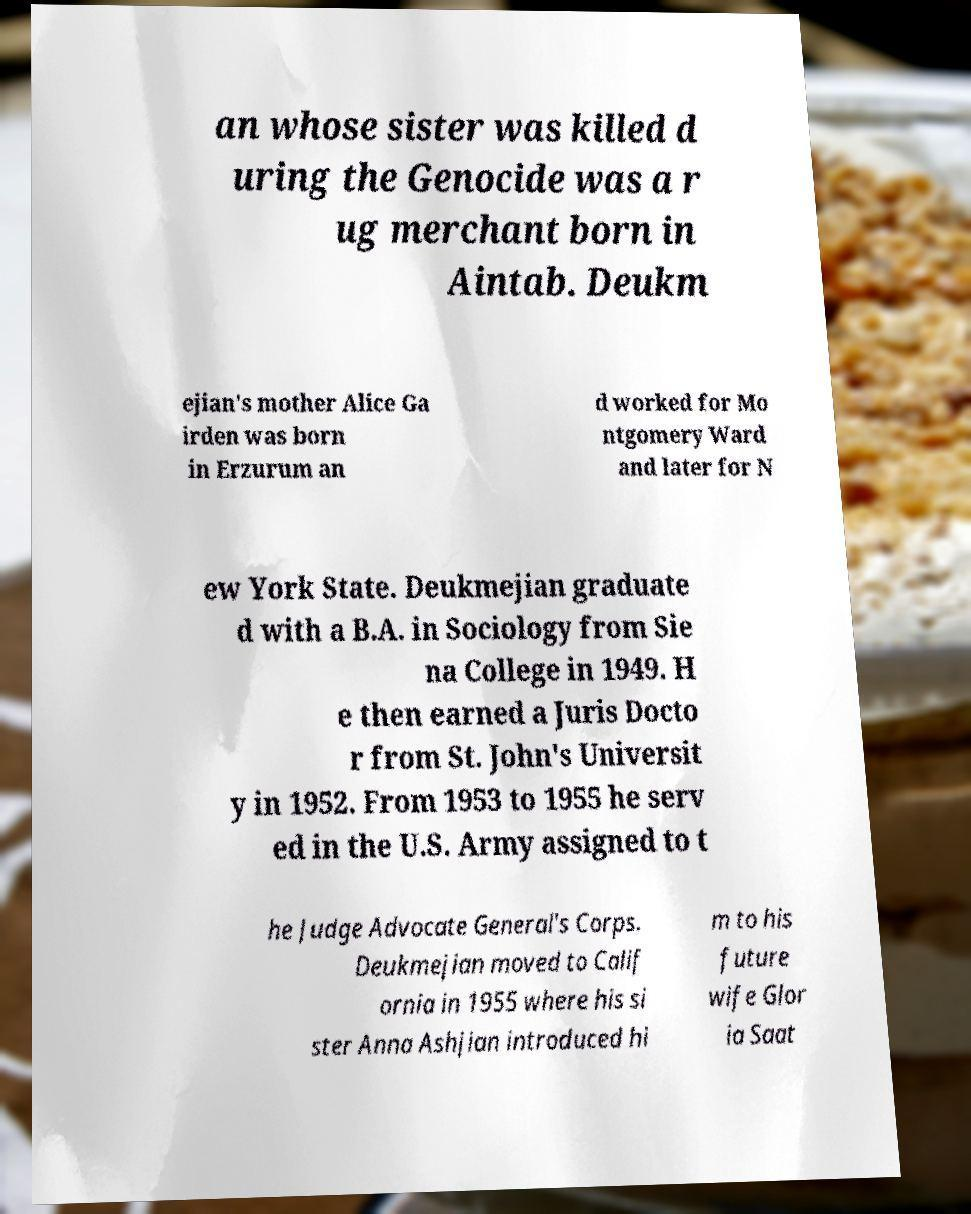Can you accurately transcribe the text from the provided image for me? an whose sister was killed d uring the Genocide was a r ug merchant born in Aintab. Deukm ejian's mother Alice Ga irden was born in Erzurum an d worked for Mo ntgomery Ward and later for N ew York State. Deukmejian graduate d with a B.A. in Sociology from Sie na College in 1949. H e then earned a Juris Docto r from St. John's Universit y in 1952. From 1953 to 1955 he serv ed in the U.S. Army assigned to t he Judge Advocate General's Corps. Deukmejian moved to Calif ornia in 1955 where his si ster Anna Ashjian introduced hi m to his future wife Glor ia Saat 